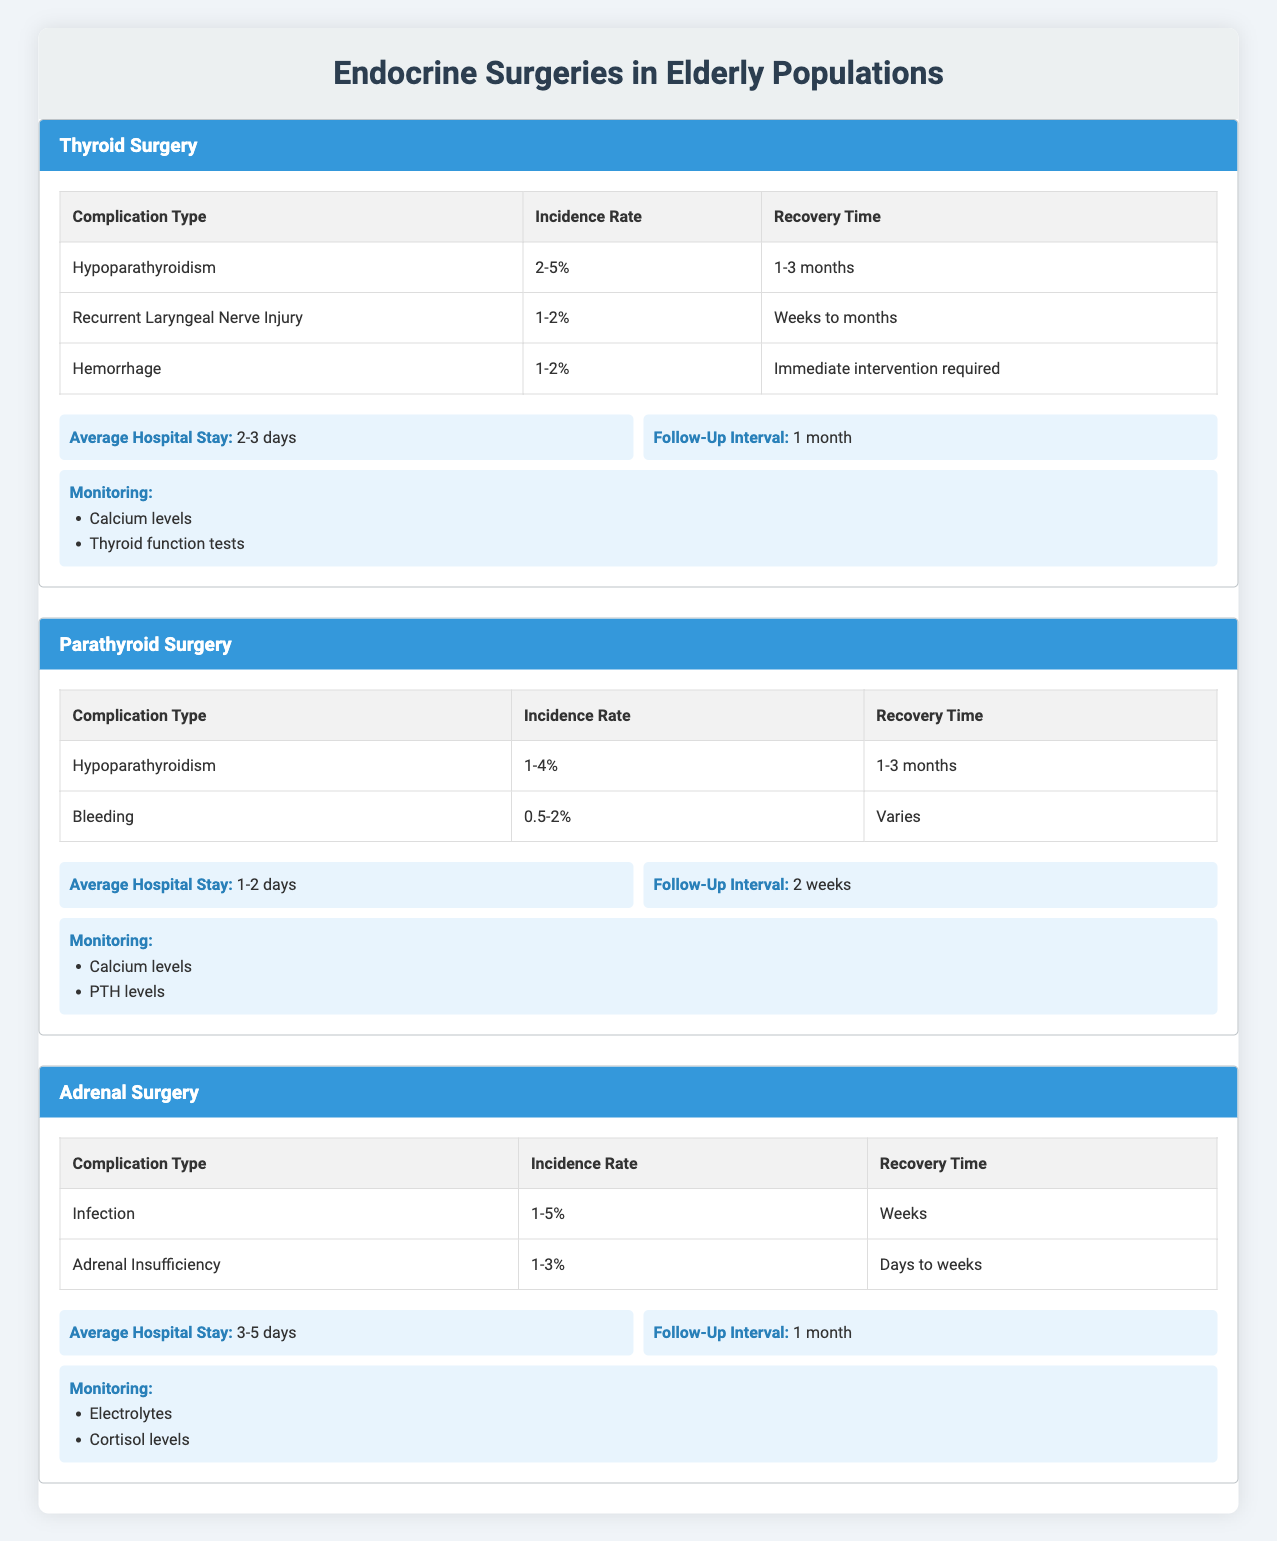What is the incidence rate of hypoparathyroidism in thyroid surgery? In the thyroid surgery section, under complications, hypoparathyroidism has an incidence rate listed as "2-5%." Therefore, the answer directly refers to the data presented in that specific section.
Answer: 2-5% How long does it typically take to recover from recurrent laryngeal nerve injury after thyroid surgery? The recovery time for recurrent laryngeal nerve injury is stated as "Weeks to months" in the thyroid surgery complications table. This information can be found clearly under the corresponding row for this complication.
Answer: Weeks to months Is the average hospital stay longer for adrenal surgery compared to parathyroid surgery? For adrenal surgery, the average hospital stay is "3-5 days," while for parathyroid surgery, it is "1-2 days." Comparing these values shows that the average hospital stay for adrenal surgery is longer than that for parathyroid surgery.
Answer: Yes What is the average recovery time for complications of adrenal surgery? Adrenal surgery has two complications listed: infection (recovery time "Weeks") and adrenal insufficiency (recovery time "Days to weeks"). To find a composite recovery time for adrenal surgery, we take these recovery times into account collectively without exact numerical averages. The longer recovery is Weeks, which represents recovery for infection. Therefore, the answer reflects the longer duration case that could be representative of a typical recovery.
Answer: Weeks Are calcium levels monitored after thyroid surgery? In the post-operative care section of thyroid surgery, it states that calcium levels are monitored as part of the post-operative care. This directly correlates to the monitoring details provided in the table.
Answer: Yes What is the incidence rate of bleeding in parathyroid surgery? The incidence rate of bleeding under the complications for parathyroid surgery is listed as "0.5-2%." This data can be retrieved directly from the table for that specific surgery type.
Answer: 0.5-2% How do the average hospital stays for thyroid and parathyroid surgeries compare? The average hospital stay for thyroid surgery is "2-3 days," while for parathyroid surgery, it is "1-2 days." To compare, the average hospital stay for thyroid surgery is longer than that for parathyroid surgery when evaluated directly.
Answer: Thyroid surgery is longer What is the total number of complications listed for adrenal surgery? The complications for adrenal surgery include infection and adrenal insufficiency, which amounts to a total of two complications. By counting the rows in the complications section for adrenal surgery, we obtain this value directly.
Answer: 2 Which surgery has the longest average recovery time for complications? For thyroid surgery, the longest complication recovery time is "weeks to months" (recurrent laryngeal nerve injury); for parathyroid surgery, the longest recovery time is "1-3 months" (hypoparathyroidism); for adrenal surgery, it is "weeks" (infection). When comparing the maximum recovery times, thyroid surgery's potential range exceeds the others due to the broader range stated (weeks to months). Therefore, thyroid surgery has the longest recovery time range for complications.
Answer: Thyroid surgery 